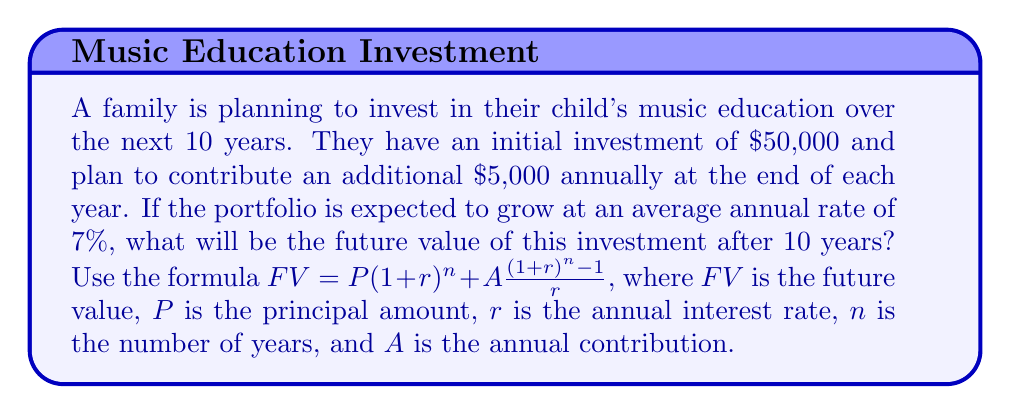Can you answer this question? Let's break this down step-by-step:

1) We are given:
   $P = \$50,000$ (initial investment)
   $A = \$5,000$ (annual contribution)
   $r = 7\% = 0.07$ (annual interest rate)
   $n = 10$ years

2) We'll use the formula: $FV = P(1+r)^n + A\frac{(1+r)^n - 1}{r}$

3) Let's calculate the first part: $P(1+r)^n$
   $$50,000(1+0.07)^{10} = 50,000(1.9672) = 98,360$$

4) Now, let's calculate the second part: $A\frac{(1+r)^n - 1}{r}$
   $$5,000\frac{(1+0.07)^{10} - 1}{0.07} = 5,000\frac{1.9672 - 1}{0.07} = 5,000(13.8168) = 69,084$$

5) Adding these two parts together:
   $$FV = 98,360 + 69,084 = 167,444$$

Therefore, the future value of the investment after 10 years will be $167,444.
Answer: $167,444 